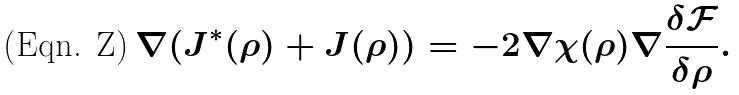Convert formula to latex. <formula><loc_0><loc_0><loc_500><loc_500>\nabla ( J ^ { * } ( \rho ) + J ( \rho ) ) = - 2 \nabla \chi ( \rho ) \nabla \frac { \delta \mathcal { F } } { \delta \rho } .</formula> 